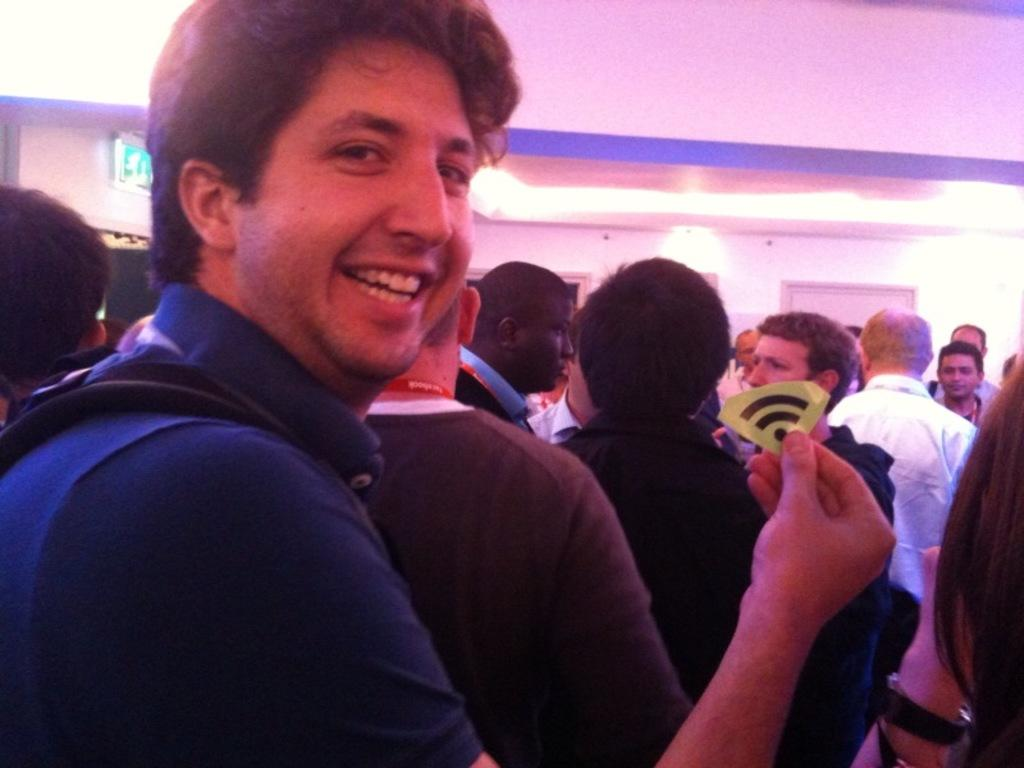How many people are present in the image? There are many people in the image. What is one person doing in the image? One person is holding something in their hand. What can be seen in the background of the image? There are lights visible in the background. What type of structure is present in the image? There is a sign board and a wall in the image. What type of bells can be heard ringing in the image? There are no bells present in the image, and therefore no sound can be heard. What is the limit of people allowed in the image? The image does not have a limit on the number of people; it simply shows many people present. 